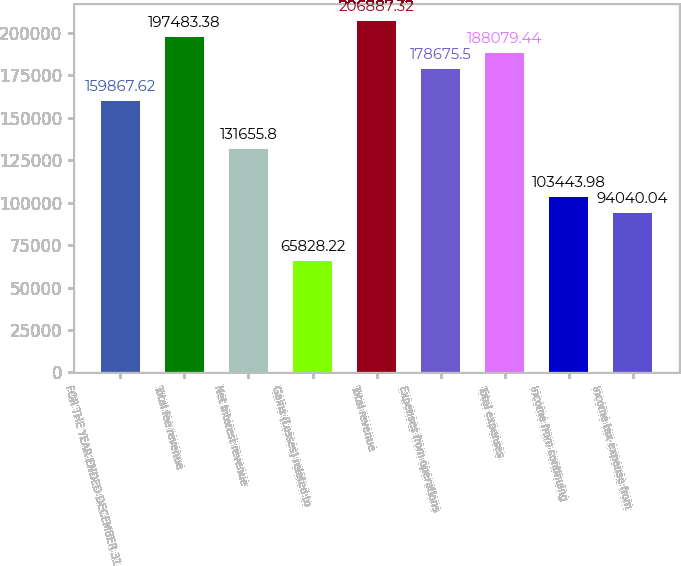<chart> <loc_0><loc_0><loc_500><loc_500><bar_chart><fcel>FOR THE YEAR ENDED DECEMBER 31<fcel>Total fee revenue<fcel>Net interest revenue<fcel>Gains (Losses) related to<fcel>Total revenue<fcel>Expenses from operations<fcel>Total expenses<fcel>Income from continuing<fcel>Income tax expense from<nl><fcel>159868<fcel>197483<fcel>131656<fcel>65828.2<fcel>206887<fcel>178676<fcel>188079<fcel>103444<fcel>94040<nl></chart> 